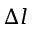Convert formula to latex. <formula><loc_0><loc_0><loc_500><loc_500>\Delta l</formula> 